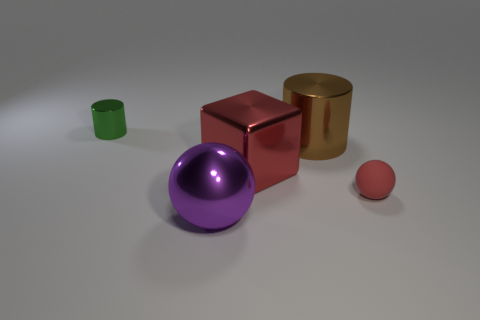Are there any other things that are the same material as the small red sphere?
Keep it short and to the point. No. There is a cube that is the same color as the tiny matte ball; what material is it?
Offer a terse response. Metal. How many cylinders are on the left side of the ball on the left side of the sphere right of the big purple ball?
Your answer should be compact. 1. There is a red ball; what number of green metal things are behind it?
Your answer should be compact. 1. What number of small balls are made of the same material as the cube?
Give a very brief answer. 0. What color is the other cylinder that is the same material as the small green cylinder?
Your response must be concise. Brown. What material is the red object right of the red thing that is left of the shiny cylinder right of the tiny shiny cylinder?
Your answer should be very brief. Rubber. Does the object that is in front of the matte thing have the same size as the red block?
Give a very brief answer. Yes. What number of small objects are either brown rubber cubes or green things?
Ensure brevity in your answer.  1. Are there any other tiny metal cylinders that have the same color as the small cylinder?
Provide a succinct answer. No. 